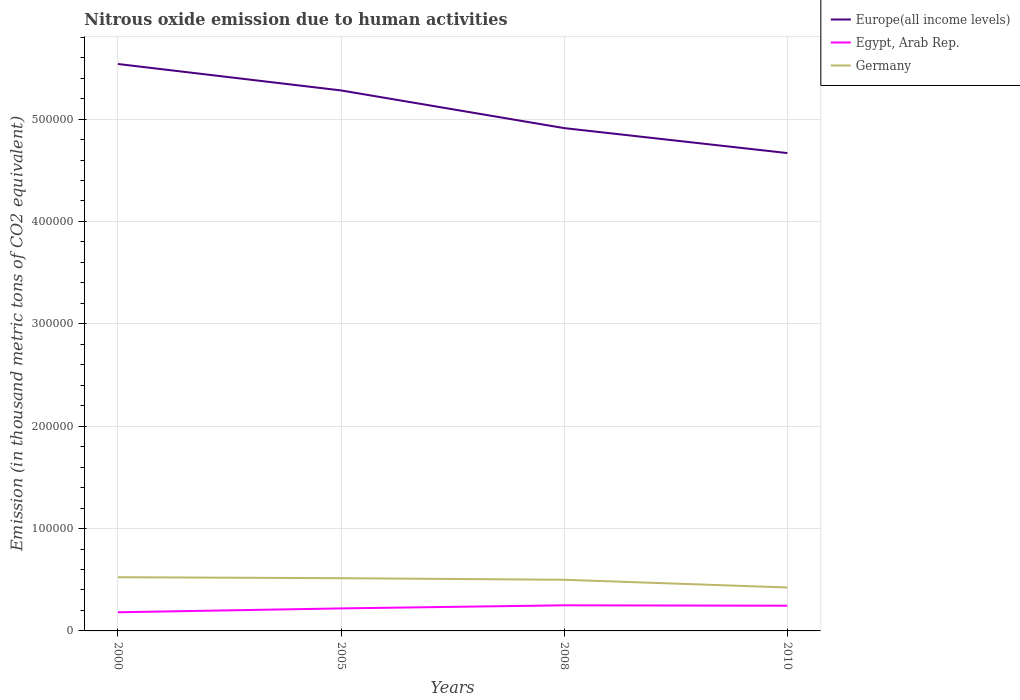Does the line corresponding to Germany intersect with the line corresponding to Egypt, Arab Rep.?
Provide a short and direct response. No. Is the number of lines equal to the number of legend labels?
Offer a terse response. Yes. Across all years, what is the maximum amount of nitrous oxide emitted in Egypt, Arab Rep.?
Provide a succinct answer. 1.82e+04. In which year was the amount of nitrous oxide emitted in Germany maximum?
Give a very brief answer. 2010. What is the total amount of nitrous oxide emitted in Egypt, Arab Rep. in the graph?
Your answer should be very brief. -2624.7. What is the difference between the highest and the second highest amount of nitrous oxide emitted in Europe(all income levels)?
Your answer should be compact. 8.70e+04. How many lines are there?
Provide a short and direct response. 3. Does the graph contain grids?
Provide a short and direct response. Yes. Where does the legend appear in the graph?
Offer a terse response. Top right. How many legend labels are there?
Keep it short and to the point. 3. How are the legend labels stacked?
Your response must be concise. Vertical. What is the title of the graph?
Your answer should be very brief. Nitrous oxide emission due to human activities. Does "Upper middle income" appear as one of the legend labels in the graph?
Your response must be concise. No. What is the label or title of the X-axis?
Make the answer very short. Years. What is the label or title of the Y-axis?
Your answer should be compact. Emission (in thousand metric tons of CO2 equivalent). What is the Emission (in thousand metric tons of CO2 equivalent) of Europe(all income levels) in 2000?
Offer a terse response. 5.54e+05. What is the Emission (in thousand metric tons of CO2 equivalent) in Egypt, Arab Rep. in 2000?
Your answer should be compact. 1.82e+04. What is the Emission (in thousand metric tons of CO2 equivalent) of Germany in 2000?
Provide a succinct answer. 5.25e+04. What is the Emission (in thousand metric tons of CO2 equivalent) of Europe(all income levels) in 2005?
Your answer should be very brief. 5.28e+05. What is the Emission (in thousand metric tons of CO2 equivalent) in Egypt, Arab Rep. in 2005?
Your response must be concise. 2.20e+04. What is the Emission (in thousand metric tons of CO2 equivalent) in Germany in 2005?
Provide a succinct answer. 5.15e+04. What is the Emission (in thousand metric tons of CO2 equivalent) in Europe(all income levels) in 2008?
Your response must be concise. 4.91e+05. What is the Emission (in thousand metric tons of CO2 equivalent) of Egypt, Arab Rep. in 2008?
Keep it short and to the point. 2.50e+04. What is the Emission (in thousand metric tons of CO2 equivalent) of Germany in 2008?
Provide a short and direct response. 5.00e+04. What is the Emission (in thousand metric tons of CO2 equivalent) in Europe(all income levels) in 2010?
Your response must be concise. 4.67e+05. What is the Emission (in thousand metric tons of CO2 equivalent) of Egypt, Arab Rep. in 2010?
Offer a terse response. 2.46e+04. What is the Emission (in thousand metric tons of CO2 equivalent) of Germany in 2010?
Your response must be concise. 4.24e+04. Across all years, what is the maximum Emission (in thousand metric tons of CO2 equivalent) of Europe(all income levels)?
Ensure brevity in your answer.  5.54e+05. Across all years, what is the maximum Emission (in thousand metric tons of CO2 equivalent) of Egypt, Arab Rep.?
Your response must be concise. 2.50e+04. Across all years, what is the maximum Emission (in thousand metric tons of CO2 equivalent) in Germany?
Your answer should be compact. 5.25e+04. Across all years, what is the minimum Emission (in thousand metric tons of CO2 equivalent) in Europe(all income levels)?
Give a very brief answer. 4.67e+05. Across all years, what is the minimum Emission (in thousand metric tons of CO2 equivalent) of Egypt, Arab Rep.?
Make the answer very short. 1.82e+04. Across all years, what is the minimum Emission (in thousand metric tons of CO2 equivalent) in Germany?
Provide a succinct answer. 4.24e+04. What is the total Emission (in thousand metric tons of CO2 equivalent) of Europe(all income levels) in the graph?
Your answer should be very brief. 2.04e+06. What is the total Emission (in thousand metric tons of CO2 equivalent) of Egypt, Arab Rep. in the graph?
Provide a succinct answer. 8.98e+04. What is the total Emission (in thousand metric tons of CO2 equivalent) in Germany in the graph?
Your answer should be compact. 1.96e+05. What is the difference between the Emission (in thousand metric tons of CO2 equivalent) of Europe(all income levels) in 2000 and that in 2005?
Provide a succinct answer. 2.58e+04. What is the difference between the Emission (in thousand metric tons of CO2 equivalent) of Egypt, Arab Rep. in 2000 and that in 2005?
Make the answer very short. -3783.9. What is the difference between the Emission (in thousand metric tons of CO2 equivalent) of Germany in 2000 and that in 2005?
Give a very brief answer. 945.2. What is the difference between the Emission (in thousand metric tons of CO2 equivalent) in Europe(all income levels) in 2000 and that in 2008?
Give a very brief answer. 6.26e+04. What is the difference between the Emission (in thousand metric tons of CO2 equivalent) of Egypt, Arab Rep. in 2000 and that in 2008?
Keep it short and to the point. -6806.9. What is the difference between the Emission (in thousand metric tons of CO2 equivalent) in Germany in 2000 and that in 2008?
Offer a terse response. 2493.2. What is the difference between the Emission (in thousand metric tons of CO2 equivalent) of Europe(all income levels) in 2000 and that in 2010?
Ensure brevity in your answer.  8.70e+04. What is the difference between the Emission (in thousand metric tons of CO2 equivalent) of Egypt, Arab Rep. in 2000 and that in 2010?
Make the answer very short. -6408.6. What is the difference between the Emission (in thousand metric tons of CO2 equivalent) of Germany in 2000 and that in 2010?
Make the answer very short. 1.00e+04. What is the difference between the Emission (in thousand metric tons of CO2 equivalent) of Europe(all income levels) in 2005 and that in 2008?
Your answer should be very brief. 3.68e+04. What is the difference between the Emission (in thousand metric tons of CO2 equivalent) of Egypt, Arab Rep. in 2005 and that in 2008?
Your answer should be very brief. -3023. What is the difference between the Emission (in thousand metric tons of CO2 equivalent) in Germany in 2005 and that in 2008?
Provide a succinct answer. 1548. What is the difference between the Emission (in thousand metric tons of CO2 equivalent) in Europe(all income levels) in 2005 and that in 2010?
Ensure brevity in your answer.  6.12e+04. What is the difference between the Emission (in thousand metric tons of CO2 equivalent) in Egypt, Arab Rep. in 2005 and that in 2010?
Give a very brief answer. -2624.7. What is the difference between the Emission (in thousand metric tons of CO2 equivalent) in Germany in 2005 and that in 2010?
Make the answer very short. 9081.9. What is the difference between the Emission (in thousand metric tons of CO2 equivalent) in Europe(all income levels) in 2008 and that in 2010?
Offer a terse response. 2.44e+04. What is the difference between the Emission (in thousand metric tons of CO2 equivalent) of Egypt, Arab Rep. in 2008 and that in 2010?
Offer a very short reply. 398.3. What is the difference between the Emission (in thousand metric tons of CO2 equivalent) in Germany in 2008 and that in 2010?
Your answer should be very brief. 7533.9. What is the difference between the Emission (in thousand metric tons of CO2 equivalent) in Europe(all income levels) in 2000 and the Emission (in thousand metric tons of CO2 equivalent) in Egypt, Arab Rep. in 2005?
Give a very brief answer. 5.32e+05. What is the difference between the Emission (in thousand metric tons of CO2 equivalent) of Europe(all income levels) in 2000 and the Emission (in thousand metric tons of CO2 equivalent) of Germany in 2005?
Provide a succinct answer. 5.02e+05. What is the difference between the Emission (in thousand metric tons of CO2 equivalent) of Egypt, Arab Rep. in 2000 and the Emission (in thousand metric tons of CO2 equivalent) of Germany in 2005?
Your response must be concise. -3.33e+04. What is the difference between the Emission (in thousand metric tons of CO2 equivalent) of Europe(all income levels) in 2000 and the Emission (in thousand metric tons of CO2 equivalent) of Egypt, Arab Rep. in 2008?
Provide a succinct answer. 5.29e+05. What is the difference between the Emission (in thousand metric tons of CO2 equivalent) of Europe(all income levels) in 2000 and the Emission (in thousand metric tons of CO2 equivalent) of Germany in 2008?
Offer a terse response. 5.04e+05. What is the difference between the Emission (in thousand metric tons of CO2 equivalent) of Egypt, Arab Rep. in 2000 and the Emission (in thousand metric tons of CO2 equivalent) of Germany in 2008?
Provide a succinct answer. -3.18e+04. What is the difference between the Emission (in thousand metric tons of CO2 equivalent) of Europe(all income levels) in 2000 and the Emission (in thousand metric tons of CO2 equivalent) of Egypt, Arab Rep. in 2010?
Provide a succinct answer. 5.29e+05. What is the difference between the Emission (in thousand metric tons of CO2 equivalent) of Europe(all income levels) in 2000 and the Emission (in thousand metric tons of CO2 equivalent) of Germany in 2010?
Provide a succinct answer. 5.11e+05. What is the difference between the Emission (in thousand metric tons of CO2 equivalent) of Egypt, Arab Rep. in 2000 and the Emission (in thousand metric tons of CO2 equivalent) of Germany in 2010?
Ensure brevity in your answer.  -2.42e+04. What is the difference between the Emission (in thousand metric tons of CO2 equivalent) of Europe(all income levels) in 2005 and the Emission (in thousand metric tons of CO2 equivalent) of Egypt, Arab Rep. in 2008?
Provide a succinct answer. 5.03e+05. What is the difference between the Emission (in thousand metric tons of CO2 equivalent) in Europe(all income levels) in 2005 and the Emission (in thousand metric tons of CO2 equivalent) in Germany in 2008?
Make the answer very short. 4.78e+05. What is the difference between the Emission (in thousand metric tons of CO2 equivalent) in Egypt, Arab Rep. in 2005 and the Emission (in thousand metric tons of CO2 equivalent) in Germany in 2008?
Give a very brief answer. -2.80e+04. What is the difference between the Emission (in thousand metric tons of CO2 equivalent) of Europe(all income levels) in 2005 and the Emission (in thousand metric tons of CO2 equivalent) of Egypt, Arab Rep. in 2010?
Give a very brief answer. 5.03e+05. What is the difference between the Emission (in thousand metric tons of CO2 equivalent) in Europe(all income levels) in 2005 and the Emission (in thousand metric tons of CO2 equivalent) in Germany in 2010?
Offer a very short reply. 4.86e+05. What is the difference between the Emission (in thousand metric tons of CO2 equivalent) in Egypt, Arab Rep. in 2005 and the Emission (in thousand metric tons of CO2 equivalent) in Germany in 2010?
Keep it short and to the point. -2.04e+04. What is the difference between the Emission (in thousand metric tons of CO2 equivalent) of Europe(all income levels) in 2008 and the Emission (in thousand metric tons of CO2 equivalent) of Egypt, Arab Rep. in 2010?
Make the answer very short. 4.67e+05. What is the difference between the Emission (in thousand metric tons of CO2 equivalent) of Europe(all income levels) in 2008 and the Emission (in thousand metric tons of CO2 equivalent) of Germany in 2010?
Provide a short and direct response. 4.49e+05. What is the difference between the Emission (in thousand metric tons of CO2 equivalent) of Egypt, Arab Rep. in 2008 and the Emission (in thousand metric tons of CO2 equivalent) of Germany in 2010?
Your answer should be compact. -1.74e+04. What is the average Emission (in thousand metric tons of CO2 equivalent) of Europe(all income levels) per year?
Offer a terse response. 5.10e+05. What is the average Emission (in thousand metric tons of CO2 equivalent) in Egypt, Arab Rep. per year?
Provide a short and direct response. 2.25e+04. What is the average Emission (in thousand metric tons of CO2 equivalent) of Germany per year?
Make the answer very short. 4.91e+04. In the year 2000, what is the difference between the Emission (in thousand metric tons of CO2 equivalent) in Europe(all income levels) and Emission (in thousand metric tons of CO2 equivalent) in Egypt, Arab Rep.?
Your response must be concise. 5.36e+05. In the year 2000, what is the difference between the Emission (in thousand metric tons of CO2 equivalent) in Europe(all income levels) and Emission (in thousand metric tons of CO2 equivalent) in Germany?
Ensure brevity in your answer.  5.01e+05. In the year 2000, what is the difference between the Emission (in thousand metric tons of CO2 equivalent) in Egypt, Arab Rep. and Emission (in thousand metric tons of CO2 equivalent) in Germany?
Your answer should be very brief. -3.42e+04. In the year 2005, what is the difference between the Emission (in thousand metric tons of CO2 equivalent) in Europe(all income levels) and Emission (in thousand metric tons of CO2 equivalent) in Egypt, Arab Rep.?
Provide a short and direct response. 5.06e+05. In the year 2005, what is the difference between the Emission (in thousand metric tons of CO2 equivalent) of Europe(all income levels) and Emission (in thousand metric tons of CO2 equivalent) of Germany?
Your response must be concise. 4.76e+05. In the year 2005, what is the difference between the Emission (in thousand metric tons of CO2 equivalent) in Egypt, Arab Rep. and Emission (in thousand metric tons of CO2 equivalent) in Germany?
Provide a short and direct response. -2.95e+04. In the year 2008, what is the difference between the Emission (in thousand metric tons of CO2 equivalent) in Europe(all income levels) and Emission (in thousand metric tons of CO2 equivalent) in Egypt, Arab Rep.?
Your answer should be very brief. 4.66e+05. In the year 2008, what is the difference between the Emission (in thousand metric tons of CO2 equivalent) in Europe(all income levels) and Emission (in thousand metric tons of CO2 equivalent) in Germany?
Make the answer very short. 4.41e+05. In the year 2008, what is the difference between the Emission (in thousand metric tons of CO2 equivalent) in Egypt, Arab Rep. and Emission (in thousand metric tons of CO2 equivalent) in Germany?
Your answer should be very brief. -2.49e+04. In the year 2010, what is the difference between the Emission (in thousand metric tons of CO2 equivalent) in Europe(all income levels) and Emission (in thousand metric tons of CO2 equivalent) in Egypt, Arab Rep.?
Give a very brief answer. 4.42e+05. In the year 2010, what is the difference between the Emission (in thousand metric tons of CO2 equivalent) of Europe(all income levels) and Emission (in thousand metric tons of CO2 equivalent) of Germany?
Ensure brevity in your answer.  4.24e+05. In the year 2010, what is the difference between the Emission (in thousand metric tons of CO2 equivalent) of Egypt, Arab Rep. and Emission (in thousand metric tons of CO2 equivalent) of Germany?
Offer a very short reply. -1.78e+04. What is the ratio of the Emission (in thousand metric tons of CO2 equivalent) in Europe(all income levels) in 2000 to that in 2005?
Your answer should be compact. 1.05. What is the ratio of the Emission (in thousand metric tons of CO2 equivalent) in Egypt, Arab Rep. in 2000 to that in 2005?
Offer a terse response. 0.83. What is the ratio of the Emission (in thousand metric tons of CO2 equivalent) in Germany in 2000 to that in 2005?
Your answer should be very brief. 1.02. What is the ratio of the Emission (in thousand metric tons of CO2 equivalent) in Europe(all income levels) in 2000 to that in 2008?
Ensure brevity in your answer.  1.13. What is the ratio of the Emission (in thousand metric tons of CO2 equivalent) in Egypt, Arab Rep. in 2000 to that in 2008?
Offer a terse response. 0.73. What is the ratio of the Emission (in thousand metric tons of CO2 equivalent) in Germany in 2000 to that in 2008?
Provide a succinct answer. 1.05. What is the ratio of the Emission (in thousand metric tons of CO2 equivalent) of Europe(all income levels) in 2000 to that in 2010?
Your answer should be very brief. 1.19. What is the ratio of the Emission (in thousand metric tons of CO2 equivalent) in Egypt, Arab Rep. in 2000 to that in 2010?
Give a very brief answer. 0.74. What is the ratio of the Emission (in thousand metric tons of CO2 equivalent) in Germany in 2000 to that in 2010?
Your response must be concise. 1.24. What is the ratio of the Emission (in thousand metric tons of CO2 equivalent) of Europe(all income levels) in 2005 to that in 2008?
Give a very brief answer. 1.07. What is the ratio of the Emission (in thousand metric tons of CO2 equivalent) of Egypt, Arab Rep. in 2005 to that in 2008?
Your answer should be compact. 0.88. What is the ratio of the Emission (in thousand metric tons of CO2 equivalent) in Germany in 2005 to that in 2008?
Provide a succinct answer. 1.03. What is the ratio of the Emission (in thousand metric tons of CO2 equivalent) in Europe(all income levels) in 2005 to that in 2010?
Make the answer very short. 1.13. What is the ratio of the Emission (in thousand metric tons of CO2 equivalent) in Egypt, Arab Rep. in 2005 to that in 2010?
Your answer should be compact. 0.89. What is the ratio of the Emission (in thousand metric tons of CO2 equivalent) of Germany in 2005 to that in 2010?
Make the answer very short. 1.21. What is the ratio of the Emission (in thousand metric tons of CO2 equivalent) of Europe(all income levels) in 2008 to that in 2010?
Your answer should be very brief. 1.05. What is the ratio of the Emission (in thousand metric tons of CO2 equivalent) in Egypt, Arab Rep. in 2008 to that in 2010?
Ensure brevity in your answer.  1.02. What is the ratio of the Emission (in thousand metric tons of CO2 equivalent) in Germany in 2008 to that in 2010?
Keep it short and to the point. 1.18. What is the difference between the highest and the second highest Emission (in thousand metric tons of CO2 equivalent) of Europe(all income levels)?
Give a very brief answer. 2.58e+04. What is the difference between the highest and the second highest Emission (in thousand metric tons of CO2 equivalent) in Egypt, Arab Rep.?
Provide a succinct answer. 398.3. What is the difference between the highest and the second highest Emission (in thousand metric tons of CO2 equivalent) of Germany?
Provide a succinct answer. 945.2. What is the difference between the highest and the lowest Emission (in thousand metric tons of CO2 equivalent) of Europe(all income levels)?
Provide a short and direct response. 8.70e+04. What is the difference between the highest and the lowest Emission (in thousand metric tons of CO2 equivalent) of Egypt, Arab Rep.?
Your response must be concise. 6806.9. What is the difference between the highest and the lowest Emission (in thousand metric tons of CO2 equivalent) of Germany?
Your answer should be very brief. 1.00e+04. 